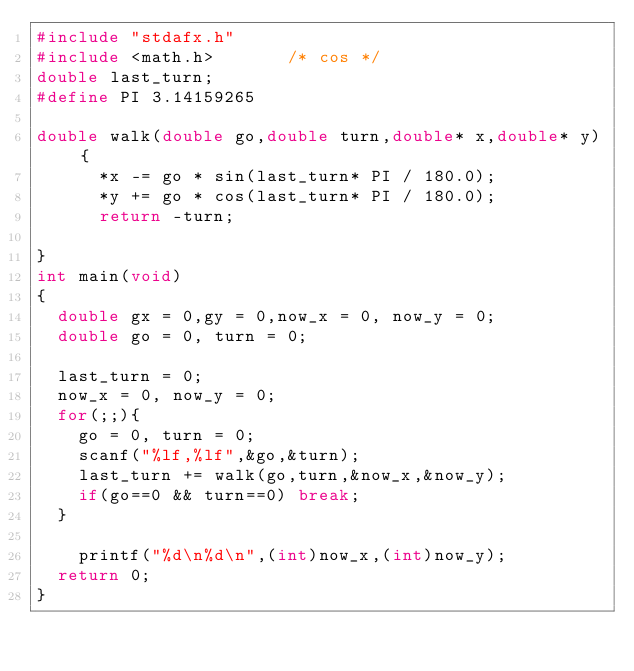<code> <loc_0><loc_0><loc_500><loc_500><_C_>#include "stdafx.h"
#include <math.h>       /* cos */
double last_turn;
#define PI 3.14159265

double walk(double go,double turn,double* x,double* y) {
			*x -= go * sin(last_turn* PI / 180.0);
			*y += go * cos(last_turn* PI / 180.0);
			return -turn; 

}
int main(void)
{
	double gx = 0,gy = 0,now_x = 0, now_y = 0;
	double go = 0, turn = 0;

	last_turn = 0;
	now_x = 0, now_y = 0;
	for(;;){
		go = 0, turn = 0;
		scanf("%lf,%lf",&go,&turn);
		last_turn += walk(go,turn,&now_x,&now_y);
		if(go==0 && turn==0) break;
	}

		printf("%d\n%d\n",(int)now_x,(int)now_y);
	return 0;
}</code> 